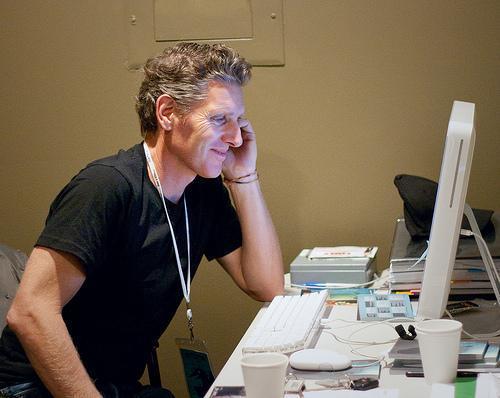How many coffee cups are there?
Give a very brief answer. 2. 